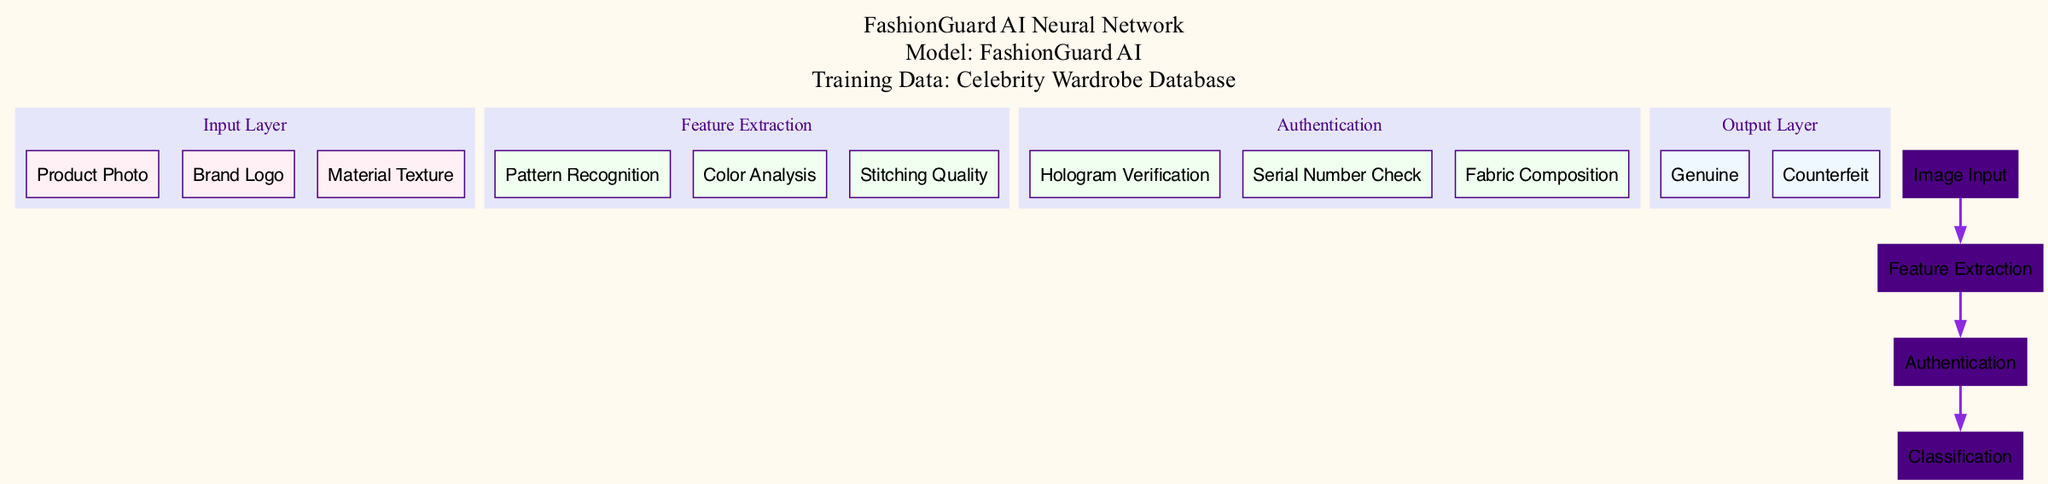What is the name of the input layer? The input layer is labeled as "Image Input" in the diagram, indicating the type of data that the network will receive.
Answer: Image Input How many nodes are in the Feature Extraction layer? The Feature Extraction layer contains three nodes: "Pattern Recognition," "Color Analysis," and "Stitching Quality." Thus, the total count is three nodes.
Answer: 3 What is the final output classification of the model? The output layer classifies items as either "Genuine" or "Counterfeit," indicating the model's final decision based on its assessments of the input data.
Answer: Genuine, Counterfeit Which layer does the "Hologram Verification" node belong to? The "Hologram Verification" node is part of the Authentication layer, specifically designed to verify the authenticity of the product.
Answer: Authentication What is the relationship between Image Input and Feature Extraction? The connection between Image Input and Feature Extraction implies that the data/images fed into the input layer are processed or analyzed by the Feature Extraction layer.
Answer: Feature Extraction How many hidden layers are present in the architecture? There are two hidden layers named "Feature Extraction" and "Authentication," which focus on analyzing features and verifying authenticity, respectively.
Answer: 2 What type of data is used for training the model? The training data is specifically referred to as the "Celebrity Wardrobe Database," indicating the source of the examples used to train the model.
Answer: Celebrity Wardrobe Database Which node connects directly to the Classification layer? The node that connects directly to the Classification layer is "Authentication," serving as the final analytical step before categorizing the input item.
Answer: Authentication What is the name of the model represented in the diagram? The model is called "FashionGuard AI," as noted in the diagram's title and additional information section.
Answer: FashionGuard AI 